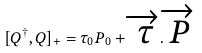Convert formula to latex. <formula><loc_0><loc_0><loc_500><loc_500>[ Q ^ { \dagger } , Q ] _ { + } = { \tau } _ { 0 } P _ { 0 } + \overrightarrow { \tau } . \overrightarrow { P }</formula> 